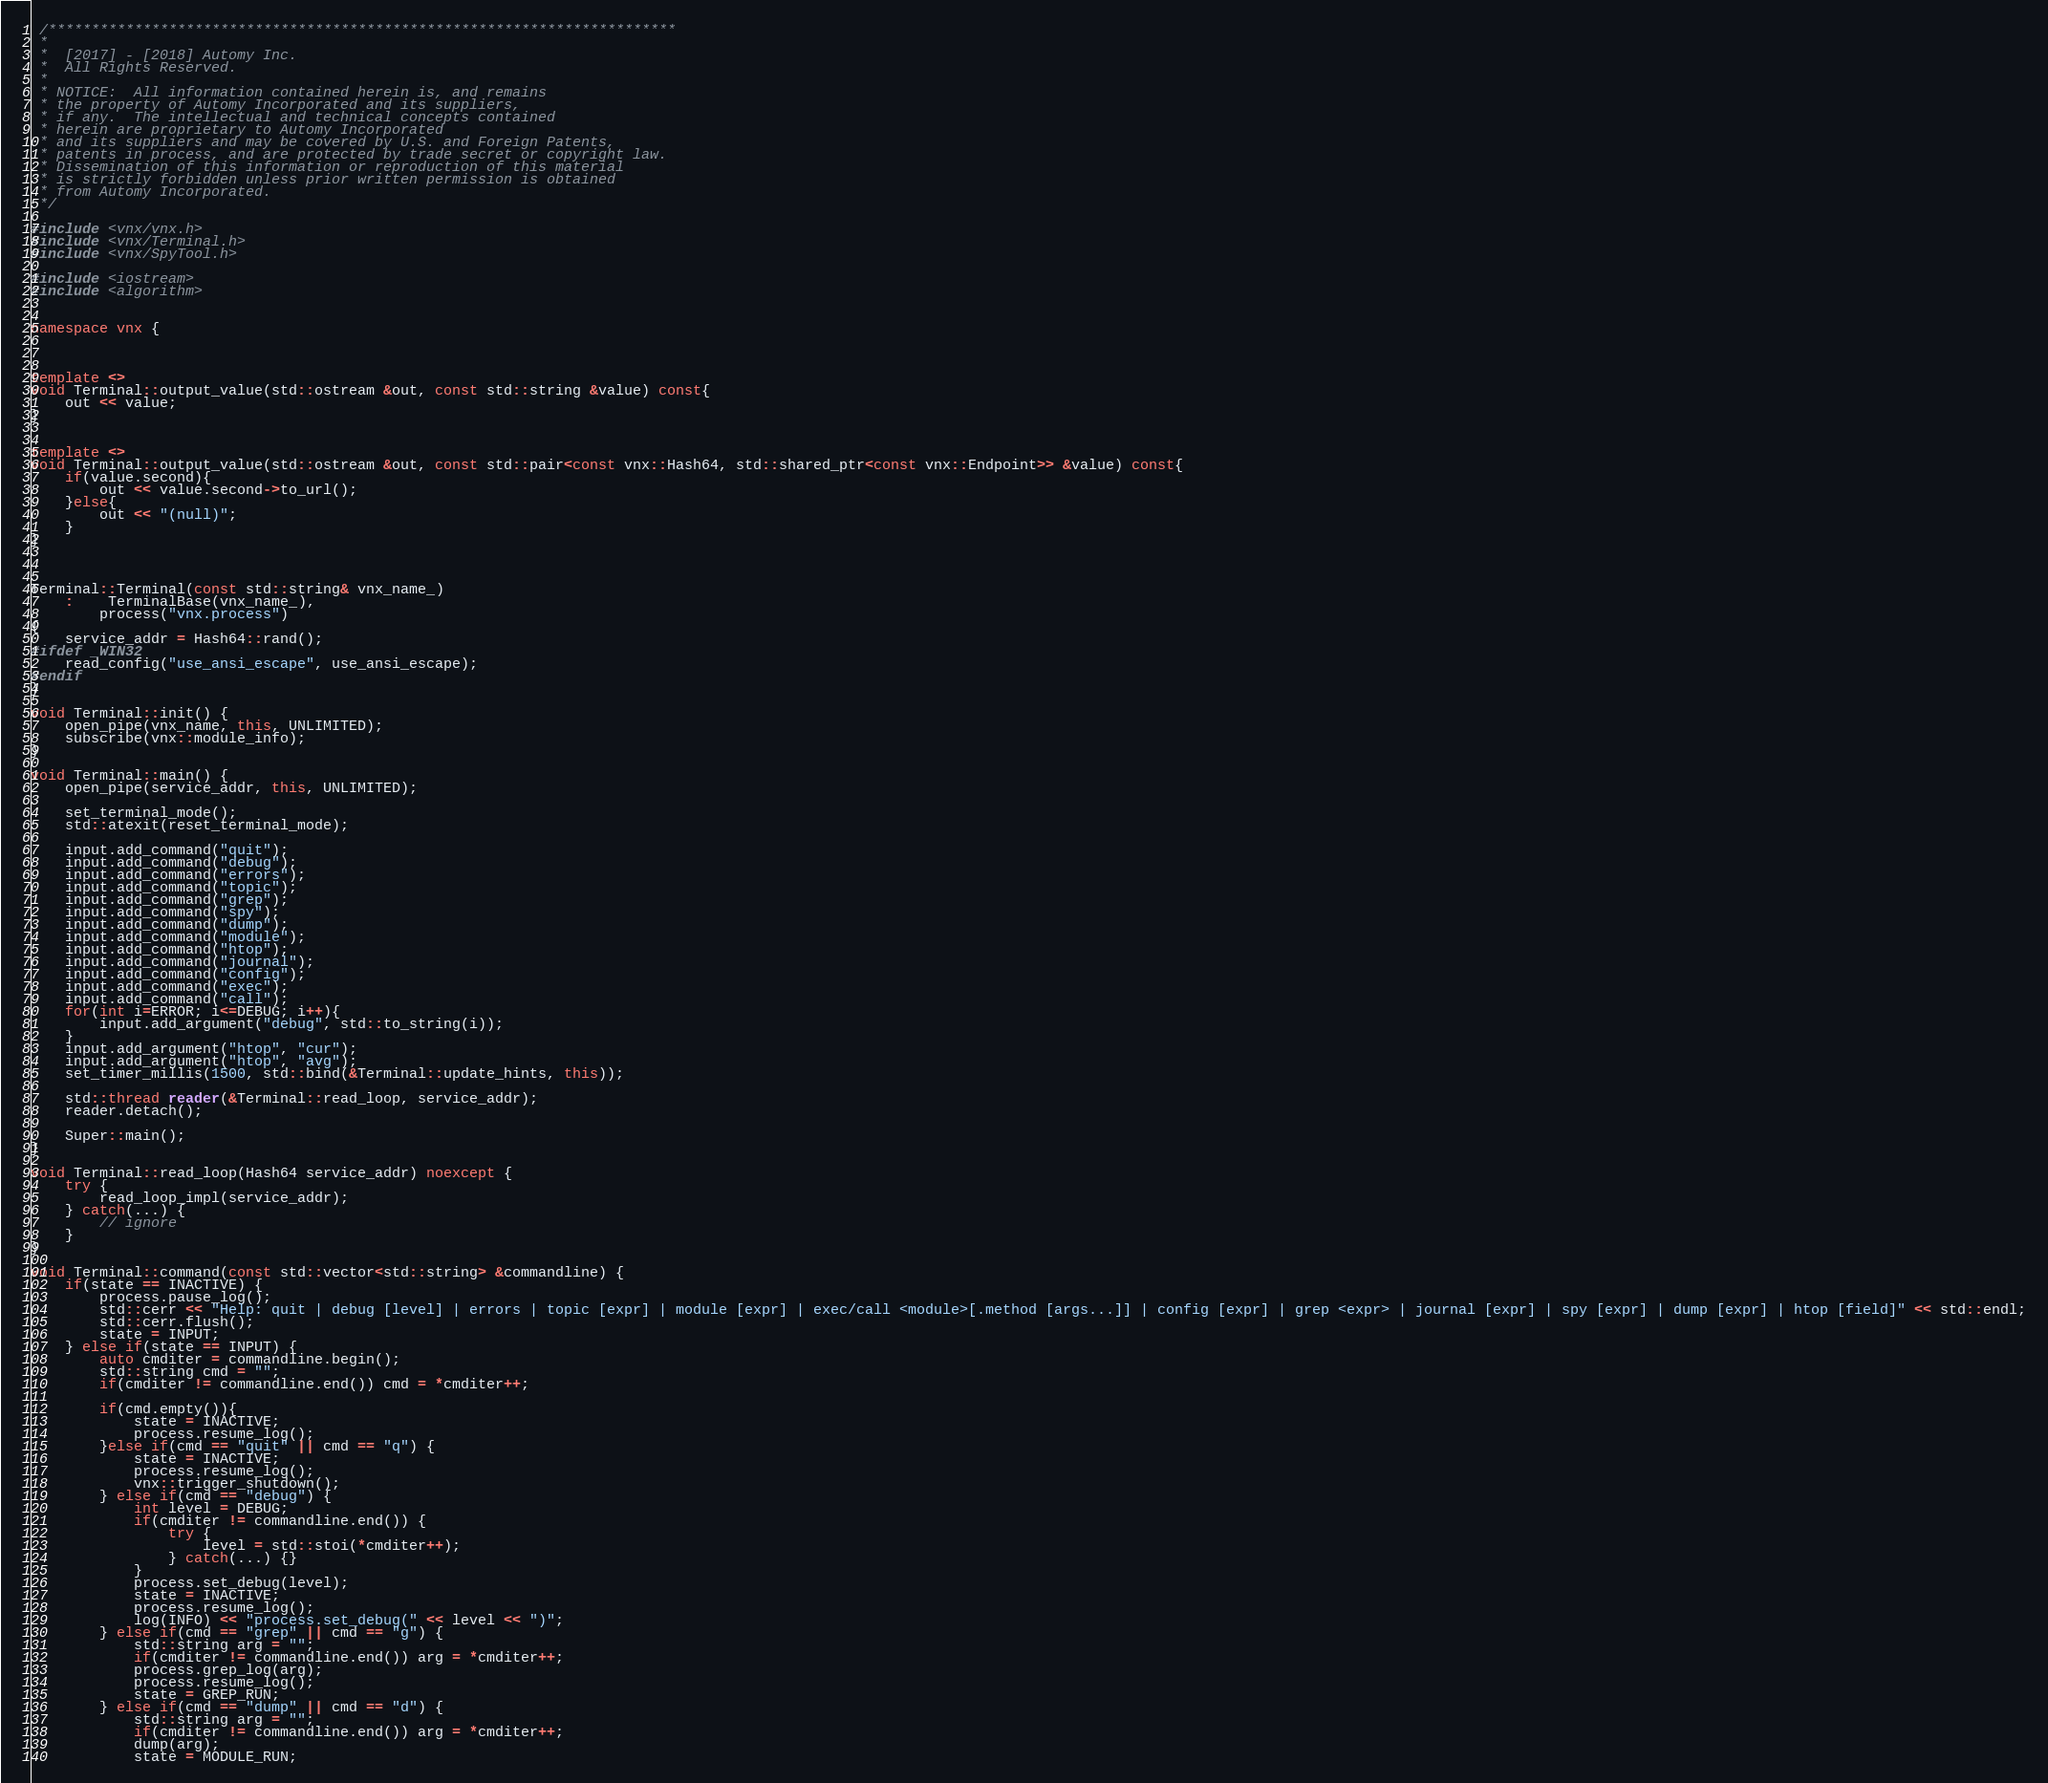Convert code to text. <code><loc_0><loc_0><loc_500><loc_500><_C++_> /*************************************************************************
 * 
 *  [2017] - [2018] Automy Inc. 
 *  All Rights Reserved.
 * 
 * NOTICE:  All information contained herein is, and remains
 * the property of Automy Incorporated and its suppliers,
 * if any.  The intellectual and technical concepts contained
 * herein are proprietary to Automy Incorporated
 * and its suppliers and may be covered by U.S. and Foreign Patents,
 * patents in process, and are protected by trade secret or copyright law.
 * Dissemination of this information or reproduction of this material
 * is strictly forbidden unless prior written permission is obtained
 * from Automy Incorporated.
 */

#include <vnx/vnx.h>
#include <vnx/Terminal.h>
#include <vnx/SpyTool.h>

#include <iostream>
#include <algorithm>


namespace vnx {



template <>
void Terminal::output_value(std::ostream &out, const std::string &value) const{
	out << value;
}


template <>
void Terminal::output_value(std::ostream &out, const std::pair<const vnx::Hash64, std::shared_ptr<const vnx::Endpoint>> &value) const{
	if(value.second){
		out << value.second->to_url();
	}else{
		out << "(null)";
	}
}



Terminal::Terminal(const std::string& vnx_name_)
	:	TerminalBase(vnx_name_),
		process("vnx.process")
{
	service_addr = Hash64::rand();
#ifdef _WIN32
	read_config("use_ansi_escape", use_ansi_escape);
#endif
}

void Terminal::init() {
	open_pipe(vnx_name, this, UNLIMITED);
	subscribe(vnx::module_info);
}

void Terminal::main() {
	open_pipe(service_addr, this, UNLIMITED);
	
	set_terminal_mode();
	std::atexit(reset_terminal_mode);

	input.add_command("quit");
	input.add_command("debug");
	input.add_command("errors");
	input.add_command("topic");
	input.add_command("grep");
	input.add_command("spy");
	input.add_command("dump");
	input.add_command("module");
	input.add_command("htop");
	input.add_command("journal");
	input.add_command("config");
	input.add_command("exec");
	input.add_command("call");
	for(int i=ERROR; i<=DEBUG; i++){
		input.add_argument("debug", std::to_string(i));
	}
	input.add_argument("htop", "cur");
	input.add_argument("htop", "avg");
	set_timer_millis(1500, std::bind(&Terminal::update_hints, this));

	std::thread reader(&Terminal::read_loop, service_addr);
	reader.detach();
	
	Super::main();
}

void Terminal::read_loop(Hash64 service_addr) noexcept {
	try {
		read_loop_impl(service_addr);
	} catch(...) {
		// ignore
	}
}

void Terminal::command(const std::vector<std::string> &commandline) {
	if(state == INACTIVE) {
		process.pause_log();
		std::cerr << "Help: quit | debug [level] | errors | topic [expr] | module [expr] | exec/call <module>[.method [args...]] | config [expr] | grep <expr> | journal [expr] | spy [expr] | dump [expr] | htop [field]" << std::endl;
		std::cerr.flush();
		state = INPUT;
	} else if(state == INPUT) {
		auto cmditer = commandline.begin();
		std::string cmd = "";
		if(cmditer != commandline.end()) cmd = *cmditer++;

		if(cmd.empty()){
			state = INACTIVE;
			process.resume_log();
		}else if(cmd == "quit" || cmd == "q") {
			state = INACTIVE;
			process.resume_log();
			vnx::trigger_shutdown();
		} else if(cmd == "debug") {
			int level = DEBUG;
			if(cmditer != commandline.end()) {
				try {
					level = std::stoi(*cmditer++);
				} catch(...) {}
			}
			process.set_debug(level);
			state = INACTIVE;
			process.resume_log();
			log(INFO) << "process.set_debug(" << level << ")";
		} else if(cmd == "grep" || cmd == "g") {
			std::string arg = "";
			if(cmditer != commandline.end()) arg = *cmditer++;
			process.grep_log(arg);
			process.resume_log();
			state = GREP_RUN;
		} else if(cmd == "dump" || cmd == "d") {
			std::string arg = "";
			if(cmditer != commandline.end()) arg = *cmditer++;
			dump(arg);
			state = MODULE_RUN;</code> 